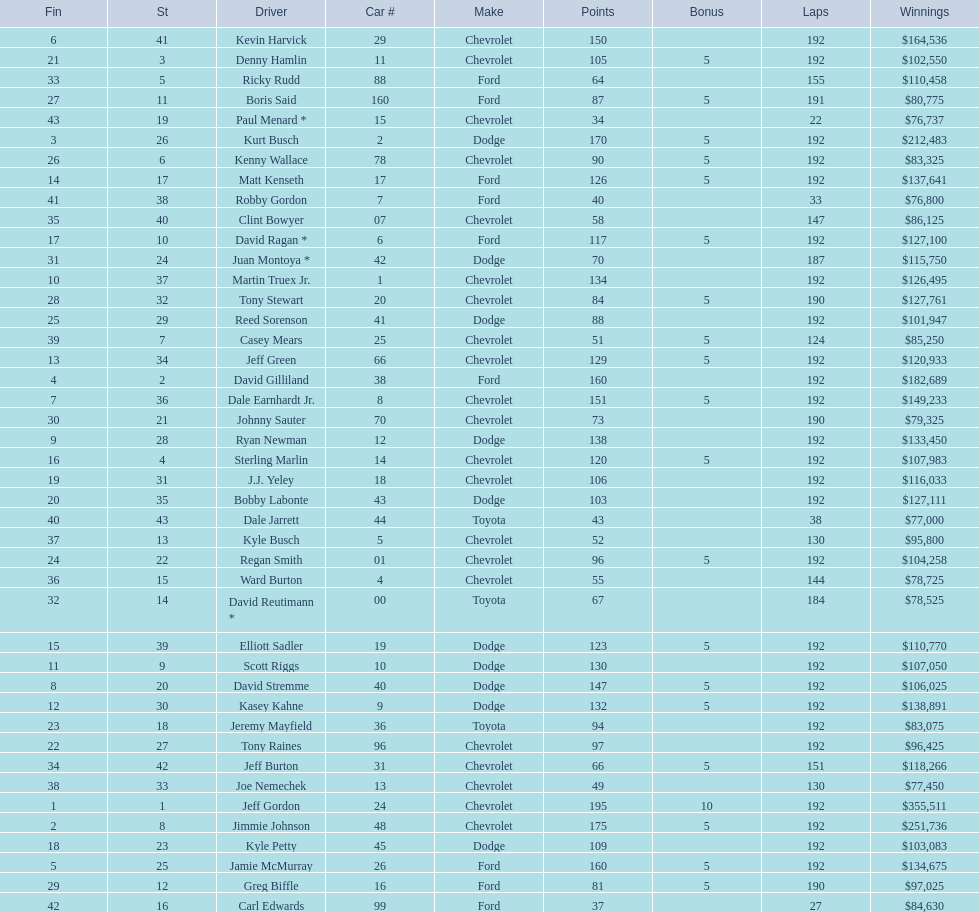What driver earned the least amount of winnings? Paul Menard *. 